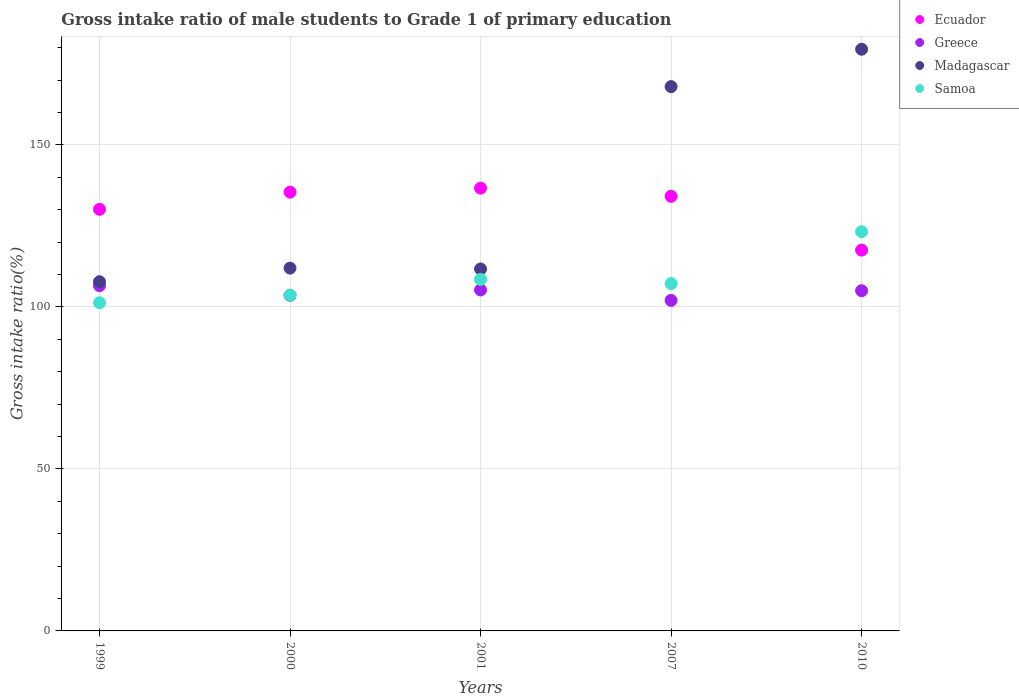How many different coloured dotlines are there?
Offer a terse response. 4. Is the number of dotlines equal to the number of legend labels?
Make the answer very short. Yes. What is the gross intake ratio in Madagascar in 2001?
Offer a very short reply. 111.71. Across all years, what is the maximum gross intake ratio in Greece?
Make the answer very short. 106.56. Across all years, what is the minimum gross intake ratio in Madagascar?
Your answer should be very brief. 107.79. In which year was the gross intake ratio in Madagascar maximum?
Provide a short and direct response. 2010. What is the total gross intake ratio in Greece in the graph?
Keep it short and to the point. 522.41. What is the difference between the gross intake ratio in Greece in 1999 and that in 2001?
Your response must be concise. 1.31. What is the difference between the gross intake ratio in Ecuador in 2000 and the gross intake ratio in Samoa in 2010?
Offer a very short reply. 12.22. What is the average gross intake ratio in Samoa per year?
Provide a succinct answer. 108.76. In the year 2010, what is the difference between the gross intake ratio in Greece and gross intake ratio in Ecuador?
Provide a short and direct response. -12.54. In how many years, is the gross intake ratio in Madagascar greater than 170 %?
Your answer should be very brief. 1. What is the ratio of the gross intake ratio in Ecuador in 1999 to that in 2010?
Provide a short and direct response. 1.11. What is the difference between the highest and the second highest gross intake ratio in Samoa?
Provide a short and direct response. 14.73. What is the difference between the highest and the lowest gross intake ratio in Samoa?
Make the answer very short. 21.92. In how many years, is the gross intake ratio in Greece greater than the average gross intake ratio in Greece taken over all years?
Provide a short and direct response. 3. Is the sum of the gross intake ratio in Samoa in 1999 and 2007 greater than the maximum gross intake ratio in Madagascar across all years?
Offer a terse response. Yes. Is it the case that in every year, the sum of the gross intake ratio in Greece and gross intake ratio in Ecuador  is greater than the sum of gross intake ratio in Madagascar and gross intake ratio in Samoa?
Offer a terse response. No. Is it the case that in every year, the sum of the gross intake ratio in Madagascar and gross intake ratio in Ecuador  is greater than the gross intake ratio in Greece?
Your answer should be very brief. Yes. Does the gross intake ratio in Ecuador monotonically increase over the years?
Offer a terse response. No. Is the gross intake ratio in Ecuador strictly less than the gross intake ratio in Greece over the years?
Give a very brief answer. No. Are the values on the major ticks of Y-axis written in scientific E-notation?
Make the answer very short. No. Does the graph contain any zero values?
Ensure brevity in your answer.  No. How many legend labels are there?
Your answer should be compact. 4. How are the legend labels stacked?
Keep it short and to the point. Vertical. What is the title of the graph?
Give a very brief answer. Gross intake ratio of male students to Grade 1 of primary education. What is the label or title of the X-axis?
Provide a succinct answer. Years. What is the label or title of the Y-axis?
Ensure brevity in your answer.  Gross intake ratio(%). What is the Gross intake ratio(%) in Ecuador in 1999?
Offer a terse response. 130.13. What is the Gross intake ratio(%) in Greece in 1999?
Provide a succinct answer. 106.56. What is the Gross intake ratio(%) in Madagascar in 1999?
Ensure brevity in your answer.  107.79. What is the Gross intake ratio(%) of Samoa in 1999?
Ensure brevity in your answer.  101.29. What is the Gross intake ratio(%) of Ecuador in 2000?
Make the answer very short. 135.42. What is the Gross intake ratio(%) in Greece in 2000?
Your answer should be very brief. 103.6. What is the Gross intake ratio(%) of Madagascar in 2000?
Ensure brevity in your answer.  111.97. What is the Gross intake ratio(%) of Samoa in 2000?
Make the answer very short. 103.62. What is the Gross intake ratio(%) in Ecuador in 2001?
Offer a terse response. 136.66. What is the Gross intake ratio(%) of Greece in 2001?
Keep it short and to the point. 105.25. What is the Gross intake ratio(%) in Madagascar in 2001?
Offer a very short reply. 111.71. What is the Gross intake ratio(%) of Samoa in 2001?
Provide a succinct answer. 108.48. What is the Gross intake ratio(%) in Ecuador in 2007?
Offer a terse response. 134.14. What is the Gross intake ratio(%) of Greece in 2007?
Provide a succinct answer. 102.01. What is the Gross intake ratio(%) in Madagascar in 2007?
Offer a very short reply. 168. What is the Gross intake ratio(%) in Samoa in 2007?
Your answer should be compact. 107.21. What is the Gross intake ratio(%) in Ecuador in 2010?
Ensure brevity in your answer.  117.53. What is the Gross intake ratio(%) in Greece in 2010?
Your answer should be very brief. 104.99. What is the Gross intake ratio(%) of Madagascar in 2010?
Make the answer very short. 179.53. What is the Gross intake ratio(%) in Samoa in 2010?
Make the answer very short. 123.2. Across all years, what is the maximum Gross intake ratio(%) of Ecuador?
Provide a short and direct response. 136.66. Across all years, what is the maximum Gross intake ratio(%) of Greece?
Keep it short and to the point. 106.56. Across all years, what is the maximum Gross intake ratio(%) of Madagascar?
Your response must be concise. 179.53. Across all years, what is the maximum Gross intake ratio(%) of Samoa?
Provide a succinct answer. 123.2. Across all years, what is the minimum Gross intake ratio(%) in Ecuador?
Offer a terse response. 117.53. Across all years, what is the minimum Gross intake ratio(%) of Greece?
Ensure brevity in your answer.  102.01. Across all years, what is the minimum Gross intake ratio(%) of Madagascar?
Give a very brief answer. 107.79. Across all years, what is the minimum Gross intake ratio(%) of Samoa?
Provide a succinct answer. 101.29. What is the total Gross intake ratio(%) of Ecuador in the graph?
Your response must be concise. 653.88. What is the total Gross intake ratio(%) of Greece in the graph?
Provide a short and direct response. 522.41. What is the total Gross intake ratio(%) in Madagascar in the graph?
Keep it short and to the point. 679. What is the total Gross intake ratio(%) of Samoa in the graph?
Your answer should be very brief. 543.8. What is the difference between the Gross intake ratio(%) of Ecuador in 1999 and that in 2000?
Make the answer very short. -5.29. What is the difference between the Gross intake ratio(%) in Greece in 1999 and that in 2000?
Keep it short and to the point. 2.96. What is the difference between the Gross intake ratio(%) of Madagascar in 1999 and that in 2000?
Offer a very short reply. -4.18. What is the difference between the Gross intake ratio(%) in Samoa in 1999 and that in 2000?
Provide a short and direct response. -2.33. What is the difference between the Gross intake ratio(%) of Ecuador in 1999 and that in 2001?
Ensure brevity in your answer.  -6.53. What is the difference between the Gross intake ratio(%) in Greece in 1999 and that in 2001?
Make the answer very short. 1.31. What is the difference between the Gross intake ratio(%) of Madagascar in 1999 and that in 2001?
Ensure brevity in your answer.  -3.93. What is the difference between the Gross intake ratio(%) of Samoa in 1999 and that in 2001?
Keep it short and to the point. -7.19. What is the difference between the Gross intake ratio(%) in Ecuador in 1999 and that in 2007?
Your answer should be very brief. -4. What is the difference between the Gross intake ratio(%) of Greece in 1999 and that in 2007?
Give a very brief answer. 4.55. What is the difference between the Gross intake ratio(%) in Madagascar in 1999 and that in 2007?
Offer a terse response. -60.21. What is the difference between the Gross intake ratio(%) of Samoa in 1999 and that in 2007?
Provide a succinct answer. -5.92. What is the difference between the Gross intake ratio(%) of Ecuador in 1999 and that in 2010?
Your answer should be very brief. 12.6. What is the difference between the Gross intake ratio(%) in Greece in 1999 and that in 2010?
Make the answer very short. 1.56. What is the difference between the Gross intake ratio(%) of Madagascar in 1999 and that in 2010?
Offer a terse response. -71.74. What is the difference between the Gross intake ratio(%) in Samoa in 1999 and that in 2010?
Ensure brevity in your answer.  -21.92. What is the difference between the Gross intake ratio(%) of Ecuador in 2000 and that in 2001?
Keep it short and to the point. -1.24. What is the difference between the Gross intake ratio(%) of Greece in 2000 and that in 2001?
Give a very brief answer. -1.65. What is the difference between the Gross intake ratio(%) in Madagascar in 2000 and that in 2001?
Offer a very short reply. 0.26. What is the difference between the Gross intake ratio(%) in Samoa in 2000 and that in 2001?
Make the answer very short. -4.86. What is the difference between the Gross intake ratio(%) in Ecuador in 2000 and that in 2007?
Offer a very short reply. 1.29. What is the difference between the Gross intake ratio(%) in Greece in 2000 and that in 2007?
Your response must be concise. 1.59. What is the difference between the Gross intake ratio(%) of Madagascar in 2000 and that in 2007?
Offer a terse response. -56.03. What is the difference between the Gross intake ratio(%) of Samoa in 2000 and that in 2007?
Ensure brevity in your answer.  -3.59. What is the difference between the Gross intake ratio(%) of Ecuador in 2000 and that in 2010?
Your answer should be compact. 17.89. What is the difference between the Gross intake ratio(%) in Greece in 2000 and that in 2010?
Provide a short and direct response. -1.4. What is the difference between the Gross intake ratio(%) in Madagascar in 2000 and that in 2010?
Give a very brief answer. -67.56. What is the difference between the Gross intake ratio(%) in Samoa in 2000 and that in 2010?
Offer a very short reply. -19.58. What is the difference between the Gross intake ratio(%) in Ecuador in 2001 and that in 2007?
Your answer should be very brief. 2.53. What is the difference between the Gross intake ratio(%) in Greece in 2001 and that in 2007?
Ensure brevity in your answer.  3.23. What is the difference between the Gross intake ratio(%) in Madagascar in 2001 and that in 2007?
Offer a very short reply. -56.28. What is the difference between the Gross intake ratio(%) of Samoa in 2001 and that in 2007?
Provide a short and direct response. 1.27. What is the difference between the Gross intake ratio(%) of Ecuador in 2001 and that in 2010?
Your answer should be very brief. 19.13. What is the difference between the Gross intake ratio(%) in Greece in 2001 and that in 2010?
Make the answer very short. 0.25. What is the difference between the Gross intake ratio(%) of Madagascar in 2001 and that in 2010?
Offer a very short reply. -67.81. What is the difference between the Gross intake ratio(%) of Samoa in 2001 and that in 2010?
Your answer should be compact. -14.73. What is the difference between the Gross intake ratio(%) in Ecuador in 2007 and that in 2010?
Offer a terse response. 16.6. What is the difference between the Gross intake ratio(%) of Greece in 2007 and that in 2010?
Offer a terse response. -2.98. What is the difference between the Gross intake ratio(%) in Madagascar in 2007 and that in 2010?
Provide a succinct answer. -11.53. What is the difference between the Gross intake ratio(%) in Samoa in 2007 and that in 2010?
Offer a terse response. -16. What is the difference between the Gross intake ratio(%) in Ecuador in 1999 and the Gross intake ratio(%) in Greece in 2000?
Provide a succinct answer. 26.53. What is the difference between the Gross intake ratio(%) in Ecuador in 1999 and the Gross intake ratio(%) in Madagascar in 2000?
Make the answer very short. 18.16. What is the difference between the Gross intake ratio(%) of Ecuador in 1999 and the Gross intake ratio(%) of Samoa in 2000?
Your answer should be compact. 26.51. What is the difference between the Gross intake ratio(%) in Greece in 1999 and the Gross intake ratio(%) in Madagascar in 2000?
Provide a succinct answer. -5.41. What is the difference between the Gross intake ratio(%) of Greece in 1999 and the Gross intake ratio(%) of Samoa in 2000?
Make the answer very short. 2.94. What is the difference between the Gross intake ratio(%) in Madagascar in 1999 and the Gross intake ratio(%) in Samoa in 2000?
Ensure brevity in your answer.  4.17. What is the difference between the Gross intake ratio(%) in Ecuador in 1999 and the Gross intake ratio(%) in Greece in 2001?
Provide a succinct answer. 24.89. What is the difference between the Gross intake ratio(%) of Ecuador in 1999 and the Gross intake ratio(%) of Madagascar in 2001?
Your response must be concise. 18.42. What is the difference between the Gross intake ratio(%) in Ecuador in 1999 and the Gross intake ratio(%) in Samoa in 2001?
Your answer should be very brief. 21.65. What is the difference between the Gross intake ratio(%) in Greece in 1999 and the Gross intake ratio(%) in Madagascar in 2001?
Make the answer very short. -5.16. What is the difference between the Gross intake ratio(%) of Greece in 1999 and the Gross intake ratio(%) of Samoa in 2001?
Make the answer very short. -1.92. What is the difference between the Gross intake ratio(%) in Madagascar in 1999 and the Gross intake ratio(%) in Samoa in 2001?
Your response must be concise. -0.69. What is the difference between the Gross intake ratio(%) in Ecuador in 1999 and the Gross intake ratio(%) in Greece in 2007?
Provide a succinct answer. 28.12. What is the difference between the Gross intake ratio(%) in Ecuador in 1999 and the Gross intake ratio(%) in Madagascar in 2007?
Your answer should be compact. -37.86. What is the difference between the Gross intake ratio(%) of Ecuador in 1999 and the Gross intake ratio(%) of Samoa in 2007?
Provide a succinct answer. 22.93. What is the difference between the Gross intake ratio(%) of Greece in 1999 and the Gross intake ratio(%) of Madagascar in 2007?
Offer a terse response. -61.44. What is the difference between the Gross intake ratio(%) of Greece in 1999 and the Gross intake ratio(%) of Samoa in 2007?
Offer a terse response. -0.65. What is the difference between the Gross intake ratio(%) of Madagascar in 1999 and the Gross intake ratio(%) of Samoa in 2007?
Your answer should be very brief. 0.58. What is the difference between the Gross intake ratio(%) of Ecuador in 1999 and the Gross intake ratio(%) of Greece in 2010?
Your response must be concise. 25.14. What is the difference between the Gross intake ratio(%) of Ecuador in 1999 and the Gross intake ratio(%) of Madagascar in 2010?
Your answer should be compact. -49.4. What is the difference between the Gross intake ratio(%) of Ecuador in 1999 and the Gross intake ratio(%) of Samoa in 2010?
Your response must be concise. 6.93. What is the difference between the Gross intake ratio(%) in Greece in 1999 and the Gross intake ratio(%) in Madagascar in 2010?
Offer a very short reply. -72.97. What is the difference between the Gross intake ratio(%) in Greece in 1999 and the Gross intake ratio(%) in Samoa in 2010?
Keep it short and to the point. -16.65. What is the difference between the Gross intake ratio(%) in Madagascar in 1999 and the Gross intake ratio(%) in Samoa in 2010?
Provide a succinct answer. -15.42. What is the difference between the Gross intake ratio(%) in Ecuador in 2000 and the Gross intake ratio(%) in Greece in 2001?
Your answer should be very brief. 30.18. What is the difference between the Gross intake ratio(%) in Ecuador in 2000 and the Gross intake ratio(%) in Madagascar in 2001?
Give a very brief answer. 23.71. What is the difference between the Gross intake ratio(%) in Ecuador in 2000 and the Gross intake ratio(%) in Samoa in 2001?
Your answer should be compact. 26.94. What is the difference between the Gross intake ratio(%) in Greece in 2000 and the Gross intake ratio(%) in Madagascar in 2001?
Keep it short and to the point. -8.12. What is the difference between the Gross intake ratio(%) in Greece in 2000 and the Gross intake ratio(%) in Samoa in 2001?
Make the answer very short. -4.88. What is the difference between the Gross intake ratio(%) in Madagascar in 2000 and the Gross intake ratio(%) in Samoa in 2001?
Ensure brevity in your answer.  3.49. What is the difference between the Gross intake ratio(%) in Ecuador in 2000 and the Gross intake ratio(%) in Greece in 2007?
Provide a succinct answer. 33.41. What is the difference between the Gross intake ratio(%) in Ecuador in 2000 and the Gross intake ratio(%) in Madagascar in 2007?
Your response must be concise. -32.57. What is the difference between the Gross intake ratio(%) of Ecuador in 2000 and the Gross intake ratio(%) of Samoa in 2007?
Keep it short and to the point. 28.22. What is the difference between the Gross intake ratio(%) in Greece in 2000 and the Gross intake ratio(%) in Madagascar in 2007?
Provide a short and direct response. -64.4. What is the difference between the Gross intake ratio(%) of Greece in 2000 and the Gross intake ratio(%) of Samoa in 2007?
Your answer should be compact. -3.61. What is the difference between the Gross intake ratio(%) in Madagascar in 2000 and the Gross intake ratio(%) in Samoa in 2007?
Provide a short and direct response. 4.76. What is the difference between the Gross intake ratio(%) of Ecuador in 2000 and the Gross intake ratio(%) of Greece in 2010?
Give a very brief answer. 30.43. What is the difference between the Gross intake ratio(%) of Ecuador in 2000 and the Gross intake ratio(%) of Madagascar in 2010?
Give a very brief answer. -44.11. What is the difference between the Gross intake ratio(%) of Ecuador in 2000 and the Gross intake ratio(%) of Samoa in 2010?
Make the answer very short. 12.22. What is the difference between the Gross intake ratio(%) of Greece in 2000 and the Gross intake ratio(%) of Madagascar in 2010?
Your answer should be very brief. -75.93. What is the difference between the Gross intake ratio(%) of Greece in 2000 and the Gross intake ratio(%) of Samoa in 2010?
Your response must be concise. -19.61. What is the difference between the Gross intake ratio(%) in Madagascar in 2000 and the Gross intake ratio(%) in Samoa in 2010?
Make the answer very short. -11.23. What is the difference between the Gross intake ratio(%) in Ecuador in 2001 and the Gross intake ratio(%) in Greece in 2007?
Provide a succinct answer. 34.65. What is the difference between the Gross intake ratio(%) in Ecuador in 2001 and the Gross intake ratio(%) in Madagascar in 2007?
Provide a short and direct response. -31.33. What is the difference between the Gross intake ratio(%) of Ecuador in 2001 and the Gross intake ratio(%) of Samoa in 2007?
Make the answer very short. 29.46. What is the difference between the Gross intake ratio(%) in Greece in 2001 and the Gross intake ratio(%) in Madagascar in 2007?
Your answer should be compact. -62.75. What is the difference between the Gross intake ratio(%) in Greece in 2001 and the Gross intake ratio(%) in Samoa in 2007?
Your answer should be compact. -1.96. What is the difference between the Gross intake ratio(%) in Madagascar in 2001 and the Gross intake ratio(%) in Samoa in 2007?
Your response must be concise. 4.51. What is the difference between the Gross intake ratio(%) of Ecuador in 2001 and the Gross intake ratio(%) of Greece in 2010?
Provide a short and direct response. 31.67. What is the difference between the Gross intake ratio(%) of Ecuador in 2001 and the Gross intake ratio(%) of Madagascar in 2010?
Your response must be concise. -42.86. What is the difference between the Gross intake ratio(%) of Ecuador in 2001 and the Gross intake ratio(%) of Samoa in 2010?
Provide a succinct answer. 13.46. What is the difference between the Gross intake ratio(%) of Greece in 2001 and the Gross intake ratio(%) of Madagascar in 2010?
Your answer should be very brief. -74.28. What is the difference between the Gross intake ratio(%) in Greece in 2001 and the Gross intake ratio(%) in Samoa in 2010?
Provide a short and direct response. -17.96. What is the difference between the Gross intake ratio(%) in Madagascar in 2001 and the Gross intake ratio(%) in Samoa in 2010?
Offer a terse response. -11.49. What is the difference between the Gross intake ratio(%) in Ecuador in 2007 and the Gross intake ratio(%) in Greece in 2010?
Your response must be concise. 29.14. What is the difference between the Gross intake ratio(%) in Ecuador in 2007 and the Gross intake ratio(%) in Madagascar in 2010?
Give a very brief answer. -45.39. What is the difference between the Gross intake ratio(%) of Ecuador in 2007 and the Gross intake ratio(%) of Samoa in 2010?
Offer a terse response. 10.93. What is the difference between the Gross intake ratio(%) of Greece in 2007 and the Gross intake ratio(%) of Madagascar in 2010?
Keep it short and to the point. -77.52. What is the difference between the Gross intake ratio(%) of Greece in 2007 and the Gross intake ratio(%) of Samoa in 2010?
Ensure brevity in your answer.  -21.19. What is the difference between the Gross intake ratio(%) in Madagascar in 2007 and the Gross intake ratio(%) in Samoa in 2010?
Provide a succinct answer. 44.79. What is the average Gross intake ratio(%) in Ecuador per year?
Offer a very short reply. 130.78. What is the average Gross intake ratio(%) in Greece per year?
Your response must be concise. 104.48. What is the average Gross intake ratio(%) in Madagascar per year?
Offer a terse response. 135.8. What is the average Gross intake ratio(%) of Samoa per year?
Ensure brevity in your answer.  108.76. In the year 1999, what is the difference between the Gross intake ratio(%) in Ecuador and Gross intake ratio(%) in Greece?
Give a very brief answer. 23.57. In the year 1999, what is the difference between the Gross intake ratio(%) of Ecuador and Gross intake ratio(%) of Madagascar?
Offer a terse response. 22.34. In the year 1999, what is the difference between the Gross intake ratio(%) in Ecuador and Gross intake ratio(%) in Samoa?
Provide a succinct answer. 28.85. In the year 1999, what is the difference between the Gross intake ratio(%) in Greece and Gross intake ratio(%) in Madagascar?
Your answer should be compact. -1.23. In the year 1999, what is the difference between the Gross intake ratio(%) in Greece and Gross intake ratio(%) in Samoa?
Your answer should be compact. 5.27. In the year 1999, what is the difference between the Gross intake ratio(%) of Madagascar and Gross intake ratio(%) of Samoa?
Provide a short and direct response. 6.5. In the year 2000, what is the difference between the Gross intake ratio(%) in Ecuador and Gross intake ratio(%) in Greece?
Give a very brief answer. 31.82. In the year 2000, what is the difference between the Gross intake ratio(%) of Ecuador and Gross intake ratio(%) of Madagascar?
Ensure brevity in your answer.  23.45. In the year 2000, what is the difference between the Gross intake ratio(%) of Ecuador and Gross intake ratio(%) of Samoa?
Make the answer very short. 31.8. In the year 2000, what is the difference between the Gross intake ratio(%) of Greece and Gross intake ratio(%) of Madagascar?
Offer a very short reply. -8.37. In the year 2000, what is the difference between the Gross intake ratio(%) in Greece and Gross intake ratio(%) in Samoa?
Offer a very short reply. -0.02. In the year 2000, what is the difference between the Gross intake ratio(%) in Madagascar and Gross intake ratio(%) in Samoa?
Ensure brevity in your answer.  8.35. In the year 2001, what is the difference between the Gross intake ratio(%) of Ecuador and Gross intake ratio(%) of Greece?
Offer a terse response. 31.42. In the year 2001, what is the difference between the Gross intake ratio(%) in Ecuador and Gross intake ratio(%) in Madagascar?
Make the answer very short. 24.95. In the year 2001, what is the difference between the Gross intake ratio(%) of Ecuador and Gross intake ratio(%) of Samoa?
Give a very brief answer. 28.19. In the year 2001, what is the difference between the Gross intake ratio(%) of Greece and Gross intake ratio(%) of Madagascar?
Make the answer very short. -6.47. In the year 2001, what is the difference between the Gross intake ratio(%) in Greece and Gross intake ratio(%) in Samoa?
Your answer should be very brief. -3.23. In the year 2001, what is the difference between the Gross intake ratio(%) of Madagascar and Gross intake ratio(%) of Samoa?
Keep it short and to the point. 3.24. In the year 2007, what is the difference between the Gross intake ratio(%) in Ecuador and Gross intake ratio(%) in Greece?
Make the answer very short. 32.12. In the year 2007, what is the difference between the Gross intake ratio(%) of Ecuador and Gross intake ratio(%) of Madagascar?
Keep it short and to the point. -33.86. In the year 2007, what is the difference between the Gross intake ratio(%) in Ecuador and Gross intake ratio(%) in Samoa?
Your answer should be compact. 26.93. In the year 2007, what is the difference between the Gross intake ratio(%) in Greece and Gross intake ratio(%) in Madagascar?
Ensure brevity in your answer.  -65.98. In the year 2007, what is the difference between the Gross intake ratio(%) of Greece and Gross intake ratio(%) of Samoa?
Provide a succinct answer. -5.19. In the year 2007, what is the difference between the Gross intake ratio(%) in Madagascar and Gross intake ratio(%) in Samoa?
Your response must be concise. 60.79. In the year 2010, what is the difference between the Gross intake ratio(%) of Ecuador and Gross intake ratio(%) of Greece?
Provide a short and direct response. 12.54. In the year 2010, what is the difference between the Gross intake ratio(%) of Ecuador and Gross intake ratio(%) of Madagascar?
Provide a short and direct response. -62. In the year 2010, what is the difference between the Gross intake ratio(%) in Ecuador and Gross intake ratio(%) in Samoa?
Make the answer very short. -5.67. In the year 2010, what is the difference between the Gross intake ratio(%) in Greece and Gross intake ratio(%) in Madagascar?
Your answer should be compact. -74.53. In the year 2010, what is the difference between the Gross intake ratio(%) of Greece and Gross intake ratio(%) of Samoa?
Your answer should be compact. -18.21. In the year 2010, what is the difference between the Gross intake ratio(%) in Madagascar and Gross intake ratio(%) in Samoa?
Provide a succinct answer. 56.32. What is the ratio of the Gross intake ratio(%) of Ecuador in 1999 to that in 2000?
Your answer should be compact. 0.96. What is the ratio of the Gross intake ratio(%) in Greece in 1999 to that in 2000?
Your answer should be compact. 1.03. What is the ratio of the Gross intake ratio(%) in Madagascar in 1999 to that in 2000?
Ensure brevity in your answer.  0.96. What is the ratio of the Gross intake ratio(%) of Samoa in 1999 to that in 2000?
Ensure brevity in your answer.  0.98. What is the ratio of the Gross intake ratio(%) in Ecuador in 1999 to that in 2001?
Provide a short and direct response. 0.95. What is the ratio of the Gross intake ratio(%) of Greece in 1999 to that in 2001?
Offer a terse response. 1.01. What is the ratio of the Gross intake ratio(%) of Madagascar in 1999 to that in 2001?
Give a very brief answer. 0.96. What is the ratio of the Gross intake ratio(%) of Samoa in 1999 to that in 2001?
Your response must be concise. 0.93. What is the ratio of the Gross intake ratio(%) in Ecuador in 1999 to that in 2007?
Ensure brevity in your answer.  0.97. What is the ratio of the Gross intake ratio(%) in Greece in 1999 to that in 2007?
Offer a terse response. 1.04. What is the ratio of the Gross intake ratio(%) in Madagascar in 1999 to that in 2007?
Provide a short and direct response. 0.64. What is the ratio of the Gross intake ratio(%) of Samoa in 1999 to that in 2007?
Provide a short and direct response. 0.94. What is the ratio of the Gross intake ratio(%) in Ecuador in 1999 to that in 2010?
Offer a very short reply. 1.11. What is the ratio of the Gross intake ratio(%) of Greece in 1999 to that in 2010?
Offer a very short reply. 1.01. What is the ratio of the Gross intake ratio(%) of Madagascar in 1999 to that in 2010?
Keep it short and to the point. 0.6. What is the ratio of the Gross intake ratio(%) of Samoa in 1999 to that in 2010?
Give a very brief answer. 0.82. What is the ratio of the Gross intake ratio(%) of Ecuador in 2000 to that in 2001?
Make the answer very short. 0.99. What is the ratio of the Gross intake ratio(%) of Greece in 2000 to that in 2001?
Your answer should be compact. 0.98. What is the ratio of the Gross intake ratio(%) of Madagascar in 2000 to that in 2001?
Keep it short and to the point. 1. What is the ratio of the Gross intake ratio(%) of Samoa in 2000 to that in 2001?
Your answer should be compact. 0.96. What is the ratio of the Gross intake ratio(%) in Ecuador in 2000 to that in 2007?
Keep it short and to the point. 1.01. What is the ratio of the Gross intake ratio(%) in Greece in 2000 to that in 2007?
Your answer should be very brief. 1.02. What is the ratio of the Gross intake ratio(%) of Madagascar in 2000 to that in 2007?
Your answer should be compact. 0.67. What is the ratio of the Gross intake ratio(%) in Samoa in 2000 to that in 2007?
Your answer should be compact. 0.97. What is the ratio of the Gross intake ratio(%) of Ecuador in 2000 to that in 2010?
Make the answer very short. 1.15. What is the ratio of the Gross intake ratio(%) of Greece in 2000 to that in 2010?
Offer a very short reply. 0.99. What is the ratio of the Gross intake ratio(%) of Madagascar in 2000 to that in 2010?
Your response must be concise. 0.62. What is the ratio of the Gross intake ratio(%) of Samoa in 2000 to that in 2010?
Your response must be concise. 0.84. What is the ratio of the Gross intake ratio(%) in Ecuador in 2001 to that in 2007?
Make the answer very short. 1.02. What is the ratio of the Gross intake ratio(%) of Greece in 2001 to that in 2007?
Give a very brief answer. 1.03. What is the ratio of the Gross intake ratio(%) of Madagascar in 2001 to that in 2007?
Offer a very short reply. 0.67. What is the ratio of the Gross intake ratio(%) of Samoa in 2001 to that in 2007?
Provide a short and direct response. 1.01. What is the ratio of the Gross intake ratio(%) in Ecuador in 2001 to that in 2010?
Your response must be concise. 1.16. What is the ratio of the Gross intake ratio(%) in Greece in 2001 to that in 2010?
Provide a short and direct response. 1. What is the ratio of the Gross intake ratio(%) in Madagascar in 2001 to that in 2010?
Your answer should be very brief. 0.62. What is the ratio of the Gross intake ratio(%) of Samoa in 2001 to that in 2010?
Give a very brief answer. 0.88. What is the ratio of the Gross intake ratio(%) of Ecuador in 2007 to that in 2010?
Your response must be concise. 1.14. What is the ratio of the Gross intake ratio(%) in Greece in 2007 to that in 2010?
Keep it short and to the point. 0.97. What is the ratio of the Gross intake ratio(%) in Madagascar in 2007 to that in 2010?
Your answer should be very brief. 0.94. What is the ratio of the Gross intake ratio(%) of Samoa in 2007 to that in 2010?
Keep it short and to the point. 0.87. What is the difference between the highest and the second highest Gross intake ratio(%) in Ecuador?
Ensure brevity in your answer.  1.24. What is the difference between the highest and the second highest Gross intake ratio(%) of Greece?
Offer a terse response. 1.31. What is the difference between the highest and the second highest Gross intake ratio(%) in Madagascar?
Offer a very short reply. 11.53. What is the difference between the highest and the second highest Gross intake ratio(%) of Samoa?
Offer a very short reply. 14.73. What is the difference between the highest and the lowest Gross intake ratio(%) in Ecuador?
Offer a very short reply. 19.13. What is the difference between the highest and the lowest Gross intake ratio(%) of Greece?
Provide a short and direct response. 4.55. What is the difference between the highest and the lowest Gross intake ratio(%) in Madagascar?
Your answer should be very brief. 71.74. What is the difference between the highest and the lowest Gross intake ratio(%) in Samoa?
Give a very brief answer. 21.92. 